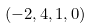<formula> <loc_0><loc_0><loc_500><loc_500>( - 2 , 4 , 1 , 0 )</formula> 